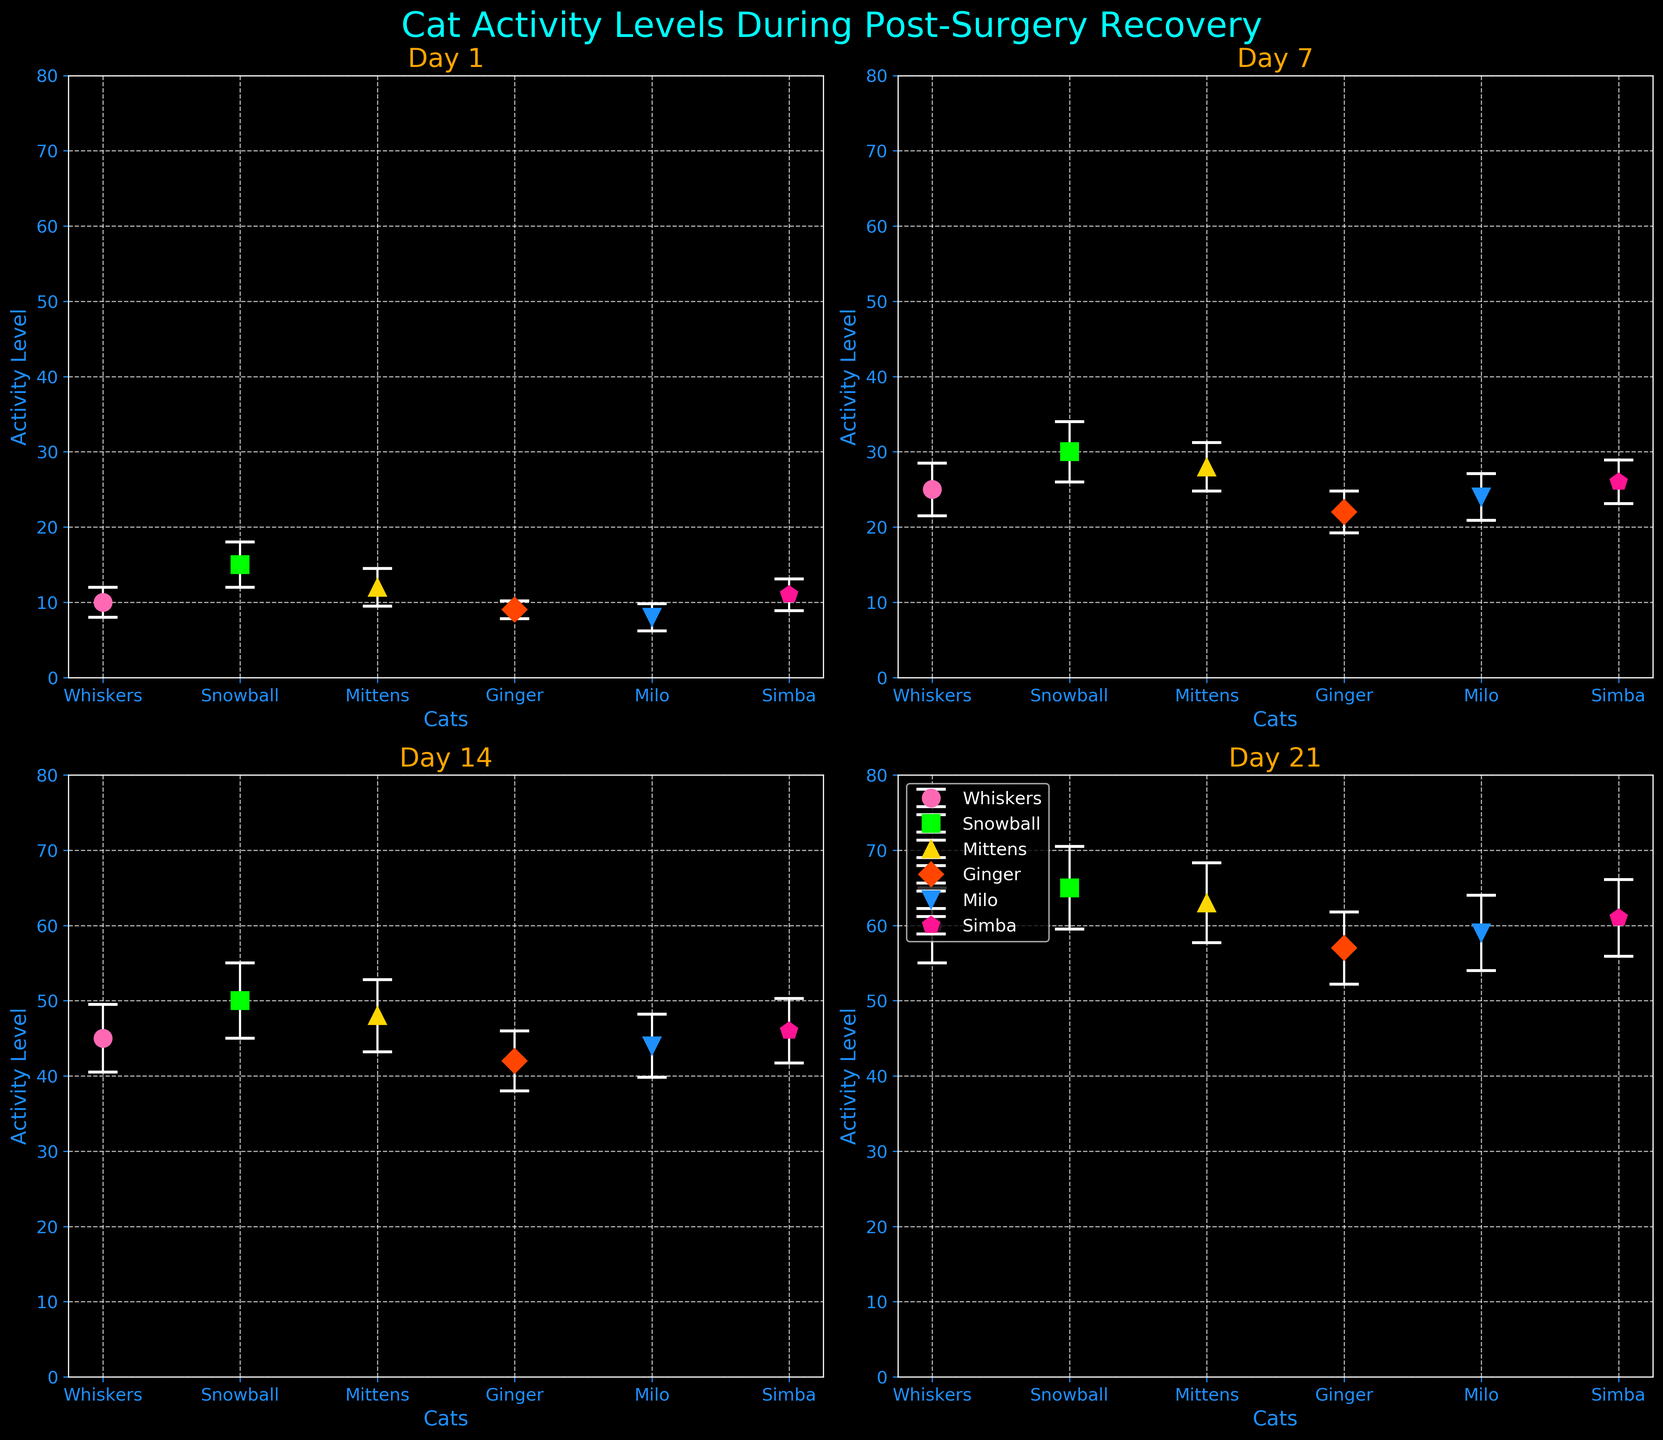What is the title of the figure? The title is usually found at the top center of the figure. In this case, it reads "Cat Activity Levels During Post-Surgery Recovery."
Answer: Cat Activity Levels During Post-Surgery Recovery What is the range of activity levels displayed on the y-axis? By examining the y-axis on any of the subplots, we can see that the range goes from 0 to 80.
Answer: 0 to 80 Which day shows the highest mean activity level for any cat? The highest mean activity level is found by examining all the subplots. Day 21 shows the highest mean activity level, with Snowball reaching 65.
Answer: Day 21 On Day 7, which cat has the lowest mean activity level? Looking at the subplot for Day 7, Ginger has the lowest mean activity level of 22.
Answer: Ginger How much did Whiskers’ activity level increase from Day 1 to Day 21? By subtracting Whiskers’ activity level on Day 1 (10) from his activity level on Day 21 (60), we find the increase is 50.
Answer: 50 Which cat shows the greatest variability in activity levels across the different days? The variability can be estimated by observing the length of the error bars across the days for each cat. Snowball has the largest standard deviations, making it the most variable.
Answer: Snowball What is the mean activity level for Milo on Day 14? Referring to the subplot for Day 14, Milo’s mean activity level is 44.
Answer: 44 Comparing Day 1 and Day 14, which cat shows the largest increase in mean activity level? Subtracting the Day 1 mean from the Day 14 mean for each cat, Snowball shows the largest increase from 15 to 50, an increase of 35.
Answer: Snowball What color represents the activity levels of Mittens? By looking at the legend or the color of the markers for Mittens on any of the subplots, we can see that Mittens is represented by yellow.
Answer: Yellow On Day 1, which cat has the highest standard deviation in activity levels? By examining the error bars on Day 1, it is evident that Snowball has the highest standard deviation of 3.
Answer: Snowball 